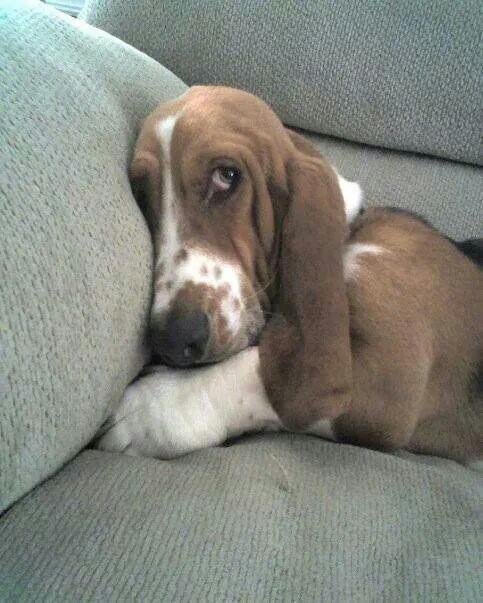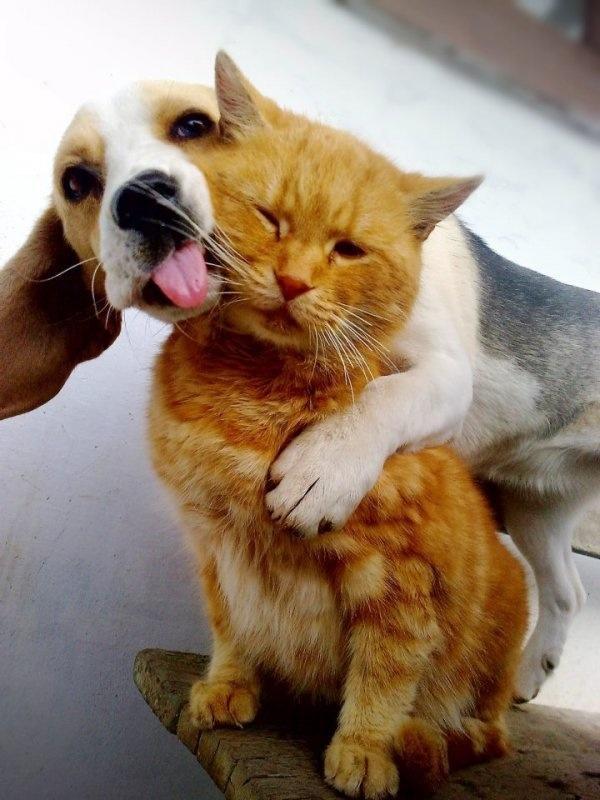The first image is the image on the left, the second image is the image on the right. Considering the images on both sides, is "One image shows a basset hound licking an animal that is not a dog." valid? Answer yes or no. Yes. The first image is the image on the left, the second image is the image on the right. Examine the images to the left and right. Is the description "In one image the only animal is the basset hound, but in the second there is a basset hound with a different species." accurate? Answer yes or no. Yes. 